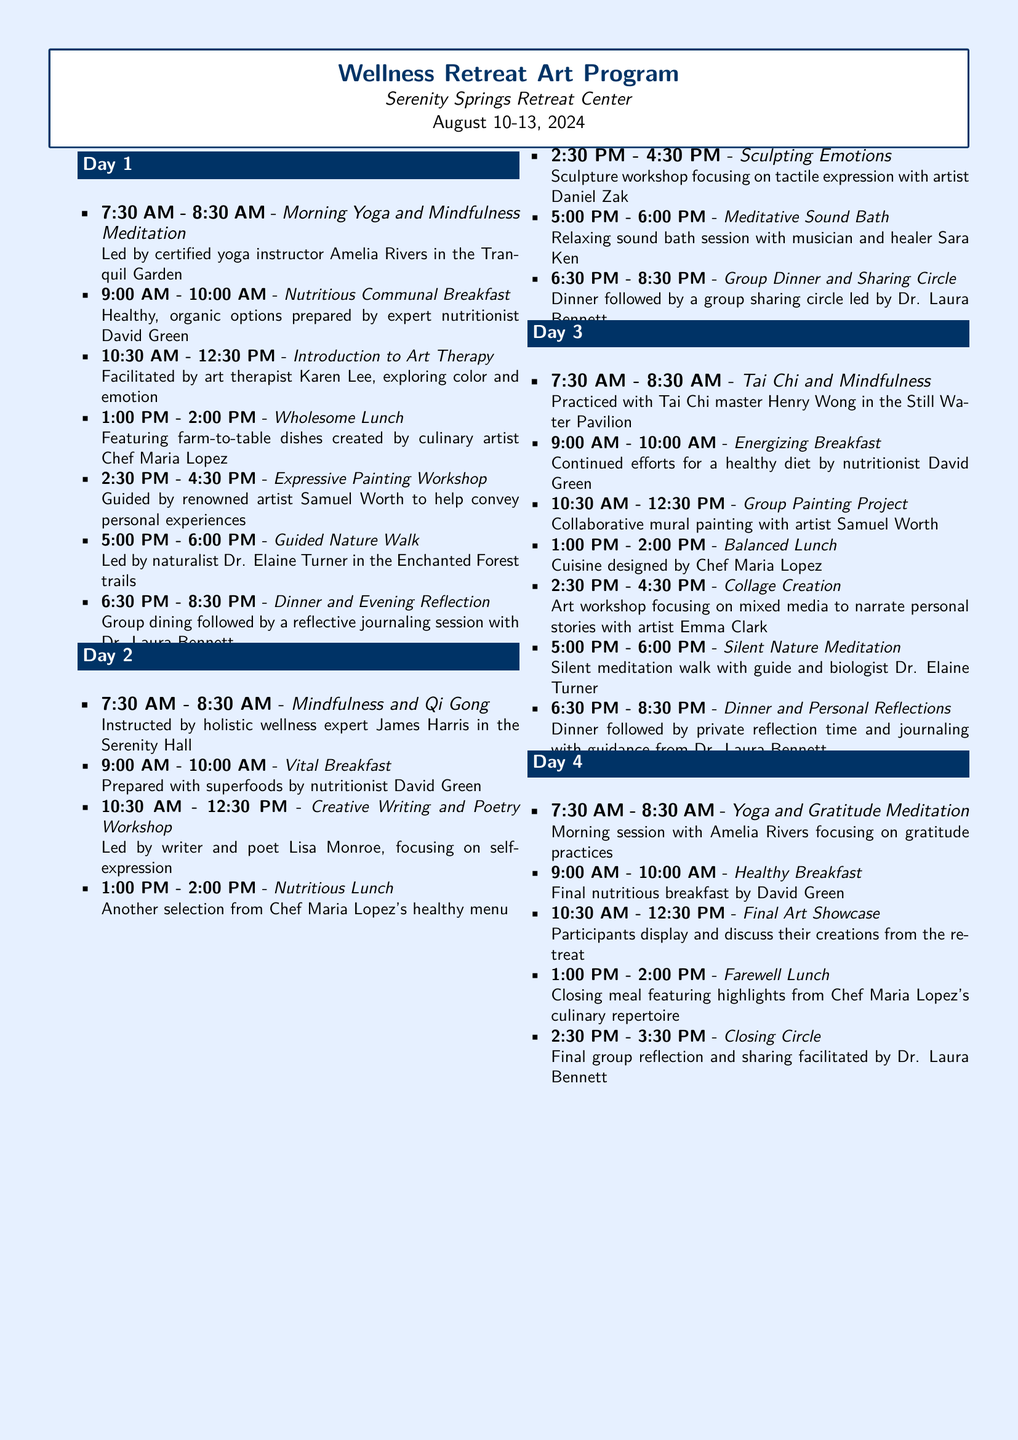what are the dates of the retreat? The dates of the retreat are listed prominently in the document, which are August 10-13, 2024.
Answer: August 10-13, 2024 who leads the morning yoga session? The morning yoga session is led by certified yoga instructor Amelia Rivers, as mentioned in the schedule for Day 1.
Answer: Amelia Rivers how many art therapy workshops are scheduled during the retreat? The document outlines the different workshops scheduled, and there are three art therapy workshops listed: Introduction to Art Therapy, Creative Writing and Poetry Workshop, and Sculpting Emotions.
Answer: 3 what type of meal is served at 1:00 PM on Day 2? The document specifies that the meal served at 1:00 PM on Day 2 is a nutritious lunch prepared with healthy options.
Answer: Nutritious Lunch which activity is scheduled for 10:30 AM on Day 4? The activity scheduled for 10:30 AM on Day 4 is the Final Art Showcase, where participants display their creations.
Answer: Final Art Showcase how many group dinners include a sharing circle? The document indicates that there are two group dinners that include a sharing circle, one on Day 2 and another on Day 3.
Answer: 2 what is the theme of the guided nature walk on Day 1? The theme of the guided nature walk on Day 1 is "led by naturalist Dr. Elaine Turner in the Enchanted Forest trails," focusing on nature exploration.
Answer: Enchanted Forest trails who facilitates the closing circle on Day 4? The closing circle on Day 4 is facilitated by Dr. Laura Bennett, as stated in the itinerary.
Answer: Dr. Laura Bennett 